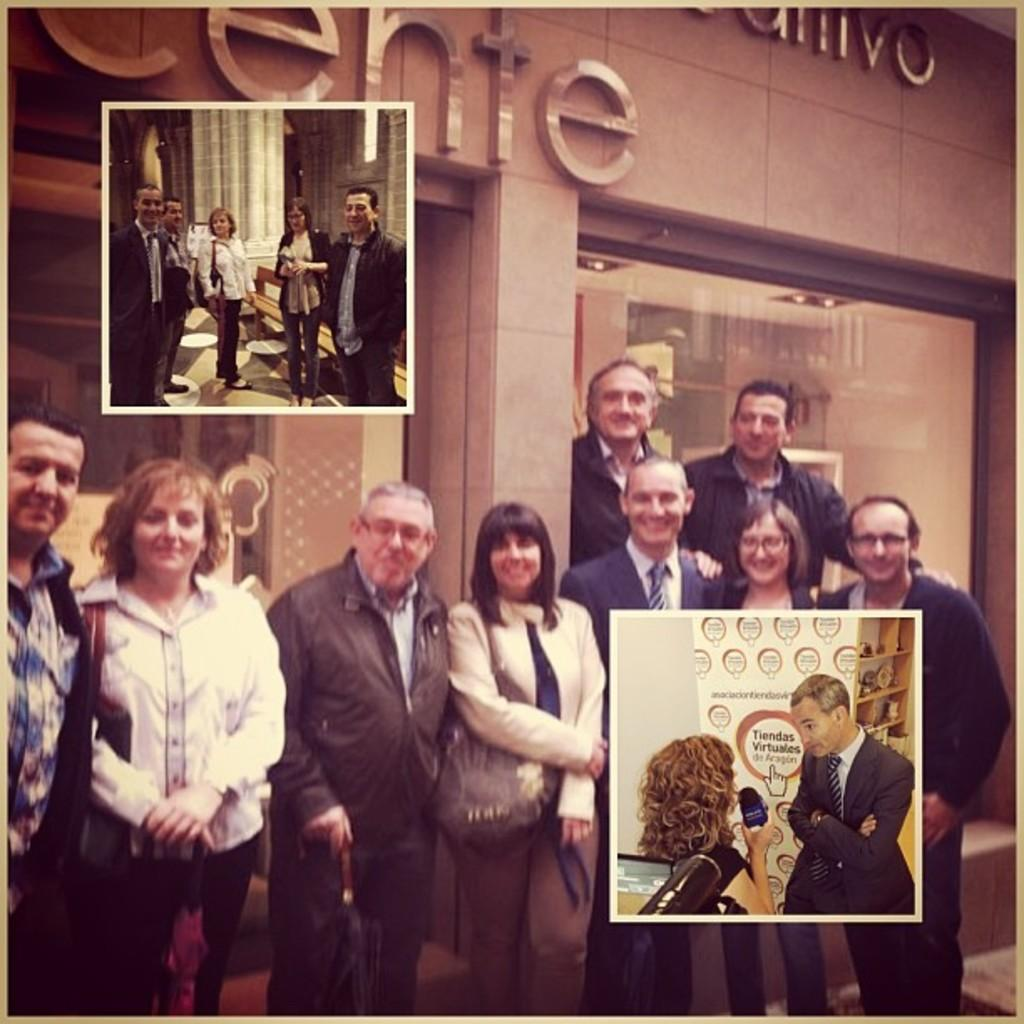What can be seen in the image? There are people standing in the image. How can you describe the attire of the people? The people are wearing different color dresses. What type of structure is present in the image? There is a building in the image. Can you identify any specific architectural feature in the image? There is a glass window in the image. What type of powder is being used by the people in the image? There is no indication of any powder being used by the people in the image. 